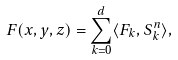<formula> <loc_0><loc_0><loc_500><loc_500>F ( x , y , z ) = \sum _ { k = 0 } ^ { d } \langle F _ { k } , S ^ { n } _ { k } \rangle ,</formula> 